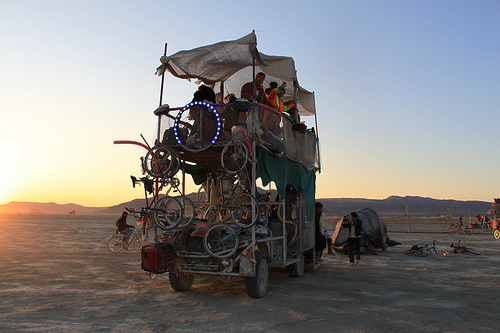<image>
Is the bike behind the truck? No. The bike is not behind the truck. From this viewpoint, the bike appears to be positioned elsewhere in the scene. 